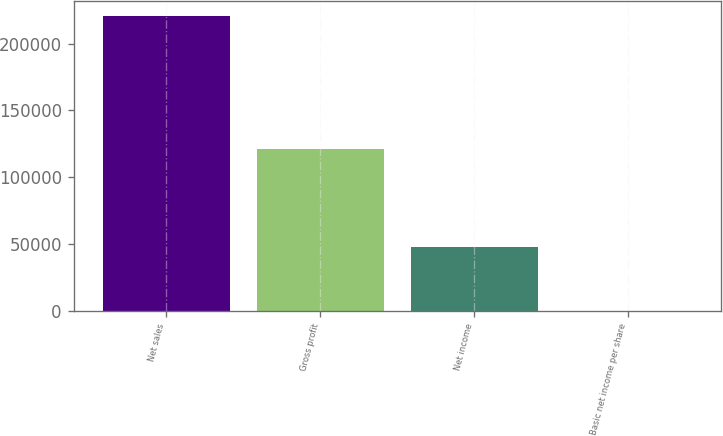Convert chart to OTSL. <chart><loc_0><loc_0><loc_500><loc_500><bar_chart><fcel>Net sales<fcel>Gross profit<fcel>Net income<fcel>Basic net income per share<nl><fcel>220949<fcel>120797<fcel>47601<fcel>0.44<nl></chart> 